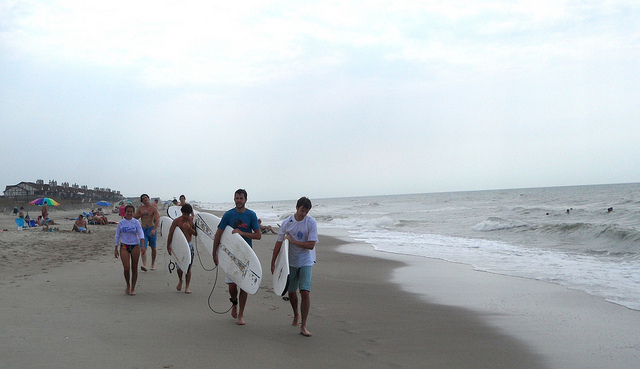How many cars are shown? There are no cars visible in the image, which features individuals walking along the beach, likely enjoying the recreational setting and coastal environment. 